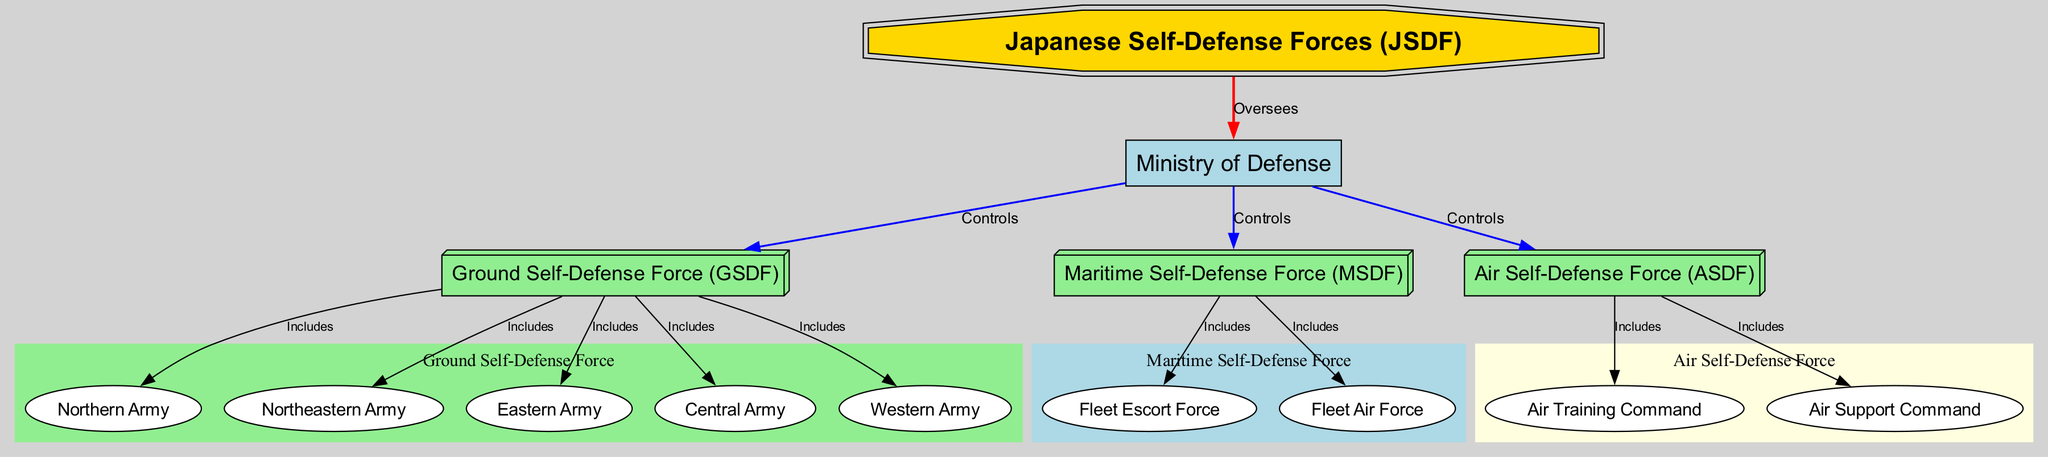What is the top unit of the Japanese Self-Defense Forces? The diagram indicates that the top unit is the "Japanese Self-Defense Forces (JSDF)", represented as the main node, which is in a double octagon shape.
Answer: Japanese Self-Defense Forces (JSDF) Who oversees the Japanese Self-Defense Forces? The connection from the "Japanese Self-Defense Forces (JSDF)" node to the "Ministry of Defense" node shows that the Ministry oversees the JSDF, as indicated by the "Oversees" label on the edge.
Answer: Ministry of Defense How many branches are controlled by the Ministry of Defense? The diagram shows three edges connecting the "Ministry of Defense" to "Ground Self-Defense Force (GSDF)", "Maritime Self-Defense Force (MSDF)", and "Air Self-Defense Force (ASDF)", indicating three branches controlled by the Ministry of Defense.
Answer: 3 What are the three components of the Ground Self-Defense Force? The diagram connects "Ground Self-Defense Force (GSDF)" to five regional nodes: "Northern Army", "Northeastern Army", "Eastern Army", "Central Army", and "Western Army". These five components indicate the structure of the GSDF.
Answer: Northern Army, Northeastern Army, Eastern Army, Central Army, Western Army Which force includes the Fleet Air Force? The "Maritime Self-Defense Force (MSDF)" node connects to the "Fleet Air Force" node as indicated by the edge labeled "Includes", indicating that the Fleet Air Force is a component of the MSDF.
Answer: Maritime Self-Defense Force (MSDF) What is the relationship between the Air Self-Defense Force and the Air Training Command? The diagram shows a directed edge from "Air Self-Defense Force (ASDF)" to "Air Training Command" labeled "Includes", indicating that the Air Training Command is part of the ASDF.
Answer: Includes How many nodes represent regional components under the Ground Self-Defense Force? Counting the edges from "Ground Self-Defense Force (GSDF)", there are five edges leading to the regional armies: Northern, Northeastern, Eastern, Central, and Western, indicating five regional components.
Answer: 5 What shape is used to represent the Ministry of Defense? The diagram specifies that the "Ministry of Defense" node is represented in a box shape, highlighted as filled with light blue color.
Answer: Box How many components fall under the Air Self-Defense Force? The Air Self-Defense Force connects to two components: "Air Training Command" and "Air Support Command", indicating that there are two components under the ASDF.
Answer: 2 What color represents the Ground Self-Defense Force in the diagram? The "Ground Self-Defense Force (GSDF)" is represented with a light green color in a 3D box shape within the diagram.
Answer: Light green 